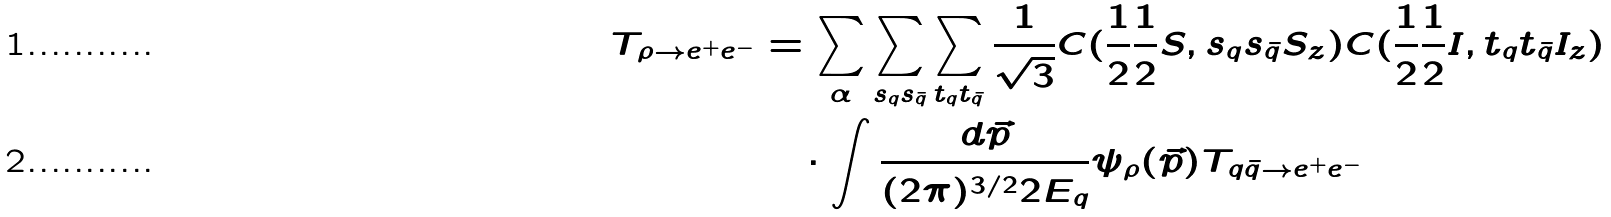<formula> <loc_0><loc_0><loc_500><loc_500>T _ { \rho \to e ^ { + } e ^ { - } } & = \sum _ { \alpha } \sum _ { s _ { q } s _ { \bar { q } } } \sum _ { t _ { q } t _ { \bar { q } } } \frac { 1 } { \sqrt { 3 } } C ( \frac { 1 } { 2 } \frac { 1 } { 2 } S , s _ { q } s _ { \bar { q } } S _ { z } ) C ( \frac { 1 } { 2 } \frac { 1 } { 2 } I , t _ { q } t _ { \bar { q } } I _ { z } ) \\ & \quad \cdot \int \frac { d \vec { p } } { ( 2 \pi ) ^ { 3 / 2 } 2 E _ { q } } \psi _ { \rho } ( \vec { p } ) T _ { q \bar { q } \to e ^ { + } e ^ { - } }</formula> 